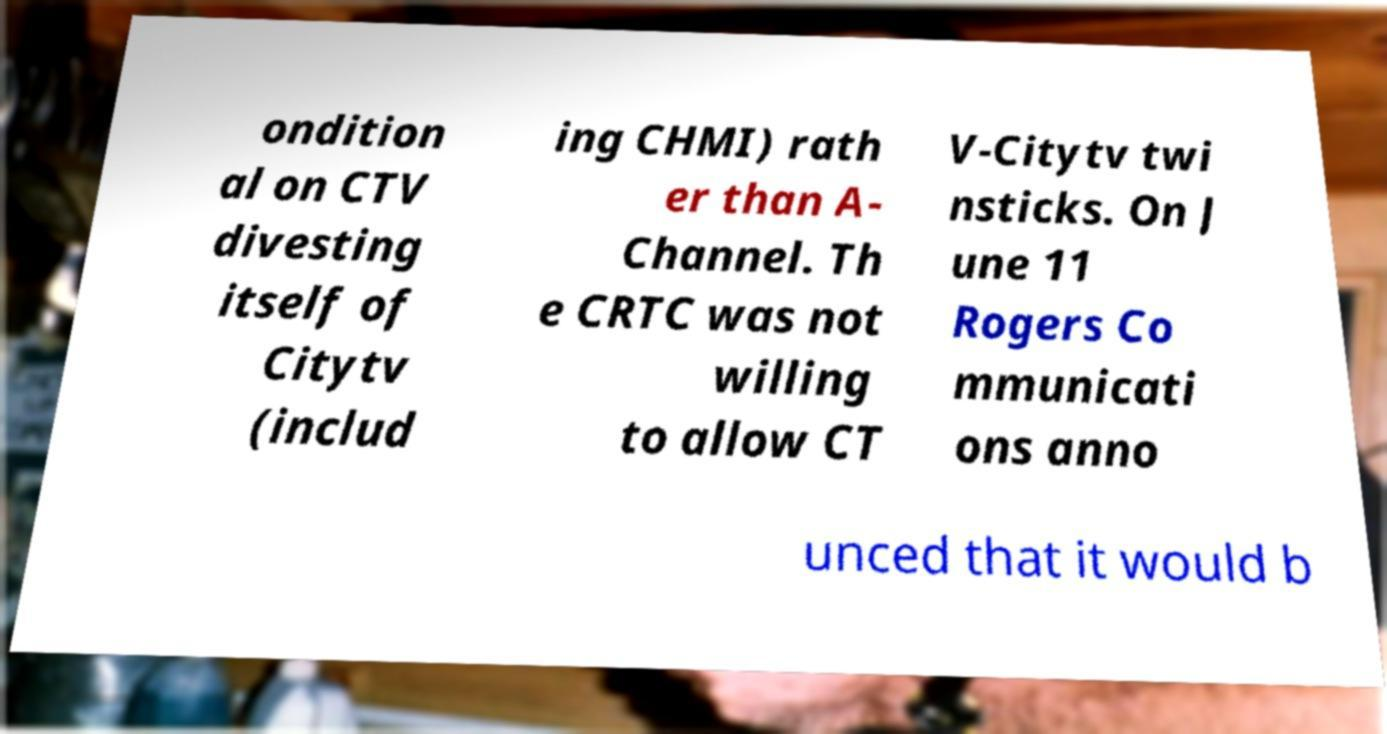Can you read and provide the text displayed in the image?This photo seems to have some interesting text. Can you extract and type it out for me? ondition al on CTV divesting itself of Citytv (includ ing CHMI) rath er than A- Channel. Th e CRTC was not willing to allow CT V-Citytv twi nsticks. On J une 11 Rogers Co mmunicati ons anno unced that it would b 